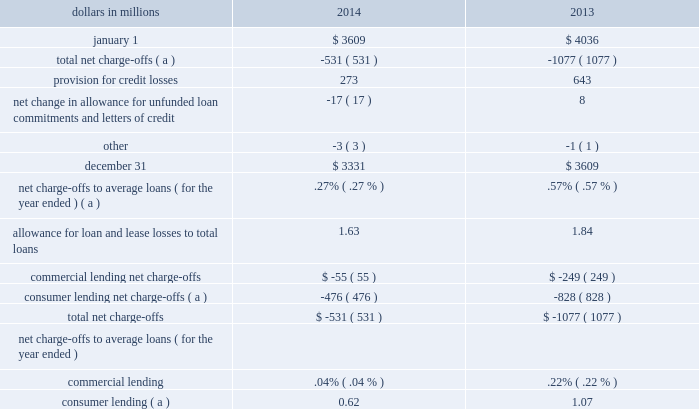2022 timing of available information , including the performance of first lien positions , and 2022 limitations of available historical data .
Pnc 2019s determination of the alll for non-impaired loans is sensitive to the risk grades assigned to commercial loans and loss rates for consumer loans .
There are several other qualitative and quantitative factors considered in determining the alll .
This sensitivity analysis does not necessarily reflect the nature and extent of future changes in the alll .
It is intended to provide insight into the impact of adverse changes to risk grades and loss rates only and does not imply any expectation of future deterioration in the risk ratings or loss rates .
Given the current processes used , we believe the risk grades and loss rates currently assigned are appropriate .
In the hypothetical event that the aggregate weighted average commercial loan risk grades would experience a 1% ( 1 % ) deterioration , assuming all other variables remain constant , the allowance for commercial loans would increase by approximately $ 35 million as of december 31 , 2014 .
In the hypothetical event that consumer loss rates would increase by 10% ( 10 % ) , assuming all other variables remain constant , the allowance for consumer loans would increase by approximately $ 37 million at december 31 , 2014 .
Purchased impaired loans are initially recorded at fair value and applicable accounting guidance prohibits the carry over or creation of valuation allowances at acquisition .
Because the initial fair values of these loans already reflect a credit component , additional reserves are established when performance is expected to be worse than our expectations as of the acquisition date .
At december 31 , 2014 , we had established reserves of $ .9 billion for purchased impaired loans .
In addition , loans ( purchased impaired and non- impaired ) acquired after january 1 , 2009 were recorded at fair value .
No allowance for loan losses was carried over and no allowance was created at the date of acquisition .
See note 4 purchased loans in the notes to consolidated financial statements in item 8 of this report for additional information .
In determining the appropriateness of the alll , we make specific allocations to impaired loans and allocations to portfolios of commercial and consumer loans .
We also allocate reserves to provide coverage for probable losses incurred in the portfolio at the balance sheet date based upon current market conditions , which may not be reflected in historical loss data .
Commercial lending is the largest category of credits and is sensitive to changes in assumptions and judgments underlying the determination of the alll .
We have allocated approximately $ 1.6 billion , or 47% ( 47 % ) , of the alll at december 31 , 2014 to the commercial lending category .
Consumer lending allocations are made based on historical loss experience adjusted for recent activity .
Approximately $ 1.7 billion , or 53% ( 53 % ) , of the alll at december 31 , 2014 has been allocated to these consumer lending categories .
In addition to the alll , we maintain an allowance for unfunded loan commitments and letters of credit .
We report this allowance as a liability on our consolidated balance sheet .
We maintain the allowance for unfunded loan commitments and letters of credit at a level we believe is appropriate to absorb estimated probable losses on these unfunded credit facilities .
We determine this amount using estimates of the probability of the ultimate funding and losses related to those credit exposures .
Other than the estimation of the probability of funding , this methodology is very similar to the one we use for determining our alll .
We refer you to note 1 accounting policies and note 3 asset quality in the notes to consolidated financial statements in item 8 of this report for further information on certain key asset quality indicators that we use to evaluate our portfolios and establish the allowances .
Table 41 : allowance for loan and lease losses .
( a ) includes charge-offs of $ 134 million taken pursuant to alignment with interagency guidance on practices for loans and lines of credit related to consumer lending in the first quarter of 2013 .
The provision for credit losses totaled $ 273 million for 2014 compared to $ 643 million for 2013 .
The primary drivers of the decrease to the provision were improved overall credit quality , including lower consumer loan delinquencies , and the increasing value of residential real estate which resulted in greater expected cash flows from our purchased impaired loans .
For 2014 , the provision for commercial lending credit losses increased by $ 64 million , or 178% ( 178 % ) , from 2013 primarily due to continued growth in the commercial book , paired with slowing of the reserve releases related to credit quality improvement .
The provision for consumer lending credit losses decreased $ 434 million , or 71% ( 71 % ) , from 2013 .
The pnc financial services group , inc .
2013 form 10-k 81 .
What was the ratio of the provision for credit losses in 2014 compared 2013 .? 
Computations: (273 / 643)
Answer: 0.42457. 2022 timing of available information , including the performance of first lien positions , and 2022 limitations of available historical data .
Pnc 2019s determination of the alll for non-impaired loans is sensitive to the risk grades assigned to commercial loans and loss rates for consumer loans .
There are several other qualitative and quantitative factors considered in determining the alll .
This sensitivity analysis does not necessarily reflect the nature and extent of future changes in the alll .
It is intended to provide insight into the impact of adverse changes to risk grades and loss rates only and does not imply any expectation of future deterioration in the risk ratings or loss rates .
Given the current processes used , we believe the risk grades and loss rates currently assigned are appropriate .
In the hypothetical event that the aggregate weighted average commercial loan risk grades would experience a 1% ( 1 % ) deterioration , assuming all other variables remain constant , the allowance for commercial loans would increase by approximately $ 35 million as of december 31 , 2014 .
In the hypothetical event that consumer loss rates would increase by 10% ( 10 % ) , assuming all other variables remain constant , the allowance for consumer loans would increase by approximately $ 37 million at december 31 , 2014 .
Purchased impaired loans are initially recorded at fair value and applicable accounting guidance prohibits the carry over or creation of valuation allowances at acquisition .
Because the initial fair values of these loans already reflect a credit component , additional reserves are established when performance is expected to be worse than our expectations as of the acquisition date .
At december 31 , 2014 , we had established reserves of $ .9 billion for purchased impaired loans .
In addition , loans ( purchased impaired and non- impaired ) acquired after january 1 , 2009 were recorded at fair value .
No allowance for loan losses was carried over and no allowance was created at the date of acquisition .
See note 4 purchased loans in the notes to consolidated financial statements in item 8 of this report for additional information .
In determining the appropriateness of the alll , we make specific allocations to impaired loans and allocations to portfolios of commercial and consumer loans .
We also allocate reserves to provide coverage for probable losses incurred in the portfolio at the balance sheet date based upon current market conditions , which may not be reflected in historical loss data .
Commercial lending is the largest category of credits and is sensitive to changes in assumptions and judgments underlying the determination of the alll .
We have allocated approximately $ 1.6 billion , or 47% ( 47 % ) , of the alll at december 31 , 2014 to the commercial lending category .
Consumer lending allocations are made based on historical loss experience adjusted for recent activity .
Approximately $ 1.7 billion , or 53% ( 53 % ) , of the alll at december 31 , 2014 has been allocated to these consumer lending categories .
In addition to the alll , we maintain an allowance for unfunded loan commitments and letters of credit .
We report this allowance as a liability on our consolidated balance sheet .
We maintain the allowance for unfunded loan commitments and letters of credit at a level we believe is appropriate to absorb estimated probable losses on these unfunded credit facilities .
We determine this amount using estimates of the probability of the ultimate funding and losses related to those credit exposures .
Other than the estimation of the probability of funding , this methodology is very similar to the one we use for determining our alll .
We refer you to note 1 accounting policies and note 3 asset quality in the notes to consolidated financial statements in item 8 of this report for further information on certain key asset quality indicators that we use to evaluate our portfolios and establish the allowances .
Table 41 : allowance for loan and lease losses .
( a ) includes charge-offs of $ 134 million taken pursuant to alignment with interagency guidance on practices for loans and lines of credit related to consumer lending in the first quarter of 2013 .
The provision for credit losses totaled $ 273 million for 2014 compared to $ 643 million for 2013 .
The primary drivers of the decrease to the provision were improved overall credit quality , including lower consumer loan delinquencies , and the increasing value of residential real estate which resulted in greater expected cash flows from our purchased impaired loans .
For 2014 , the provision for commercial lending credit losses increased by $ 64 million , or 178% ( 178 % ) , from 2013 primarily due to continued growth in the commercial book , paired with slowing of the reserve releases related to credit quality improvement .
The provision for consumer lending credit losses decreased $ 434 million , or 71% ( 71 % ) , from 2013 .
The pnc financial services group , inc .
2013 form 10-k 81 .
In 2014 what was the percent of the change associated with total net charge-offs? 
Computations: (531 / 3609)
Answer: 0.14713. 